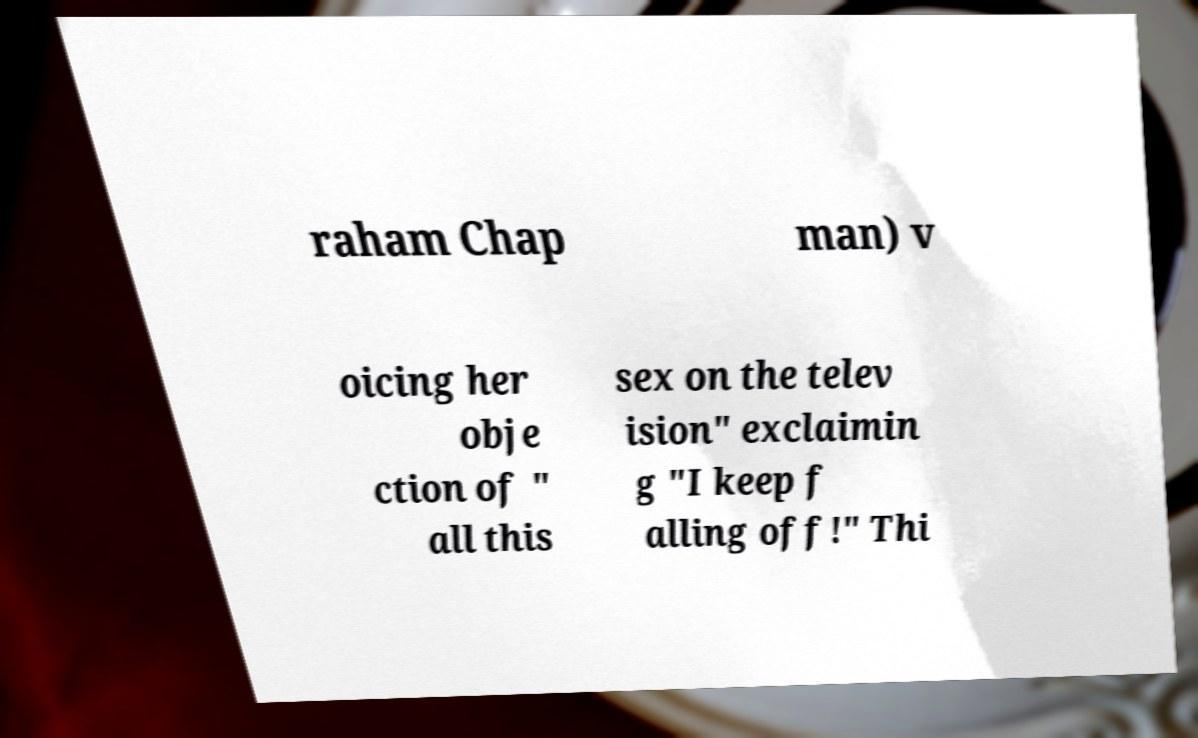Could you assist in decoding the text presented in this image and type it out clearly? raham Chap man) v oicing her obje ction of " all this sex on the telev ision" exclaimin g "I keep f alling off!" Thi 